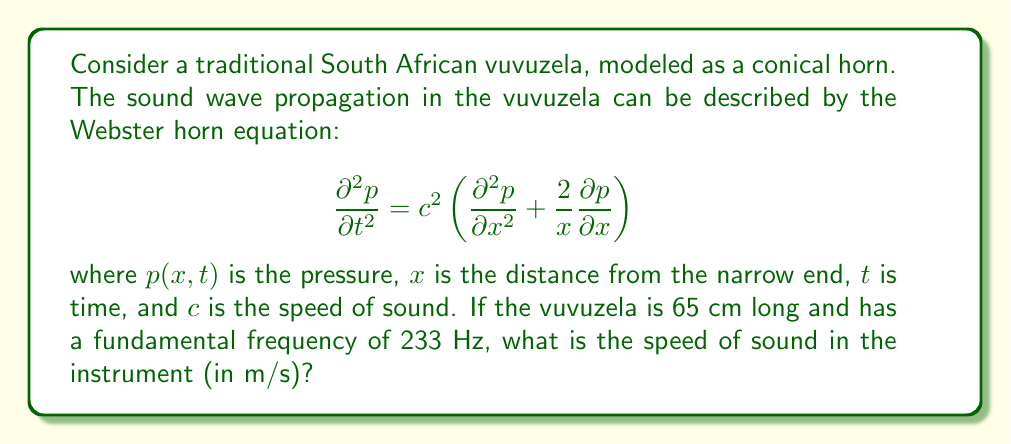Can you solve this math problem? Let's approach this step-by-step:

1) For a conical horn, the fundamental frequency $f$ is related to the speed of sound $c$ and the length of the instrument $L$ by the equation:

   $$f = \frac{c}{4L}$$

2) We are given:
   - Fundamental frequency, $f = 233$ Hz
   - Length of the vuvuzela, $L = 65$ cm = 0.65 m

3) Let's substitute these values into the equation:

   $$233 = \frac{c}{4(0.65)}$$

4) Now, let's solve for $c$:

   $$c = 233 \cdot 4 \cdot 0.65$$

5) Calculate:
   
   $$c = 233 \cdot 2.6 = 605.8$$

6) Round to the nearest whole number:

   $$c \approx 606 \text{ m/s}$$

Thus, the speed of sound in the vuvuzela is approximately 606 m/s.
Answer: 606 m/s 